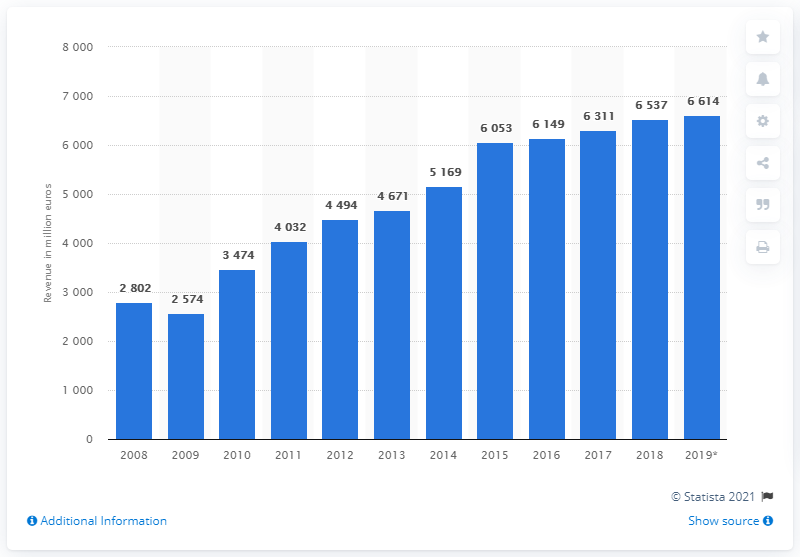Specify some key components in this picture. In 2009, Brose's revenue declined. Brose is expected to generate approximately 6,614 revenue in 2019. 